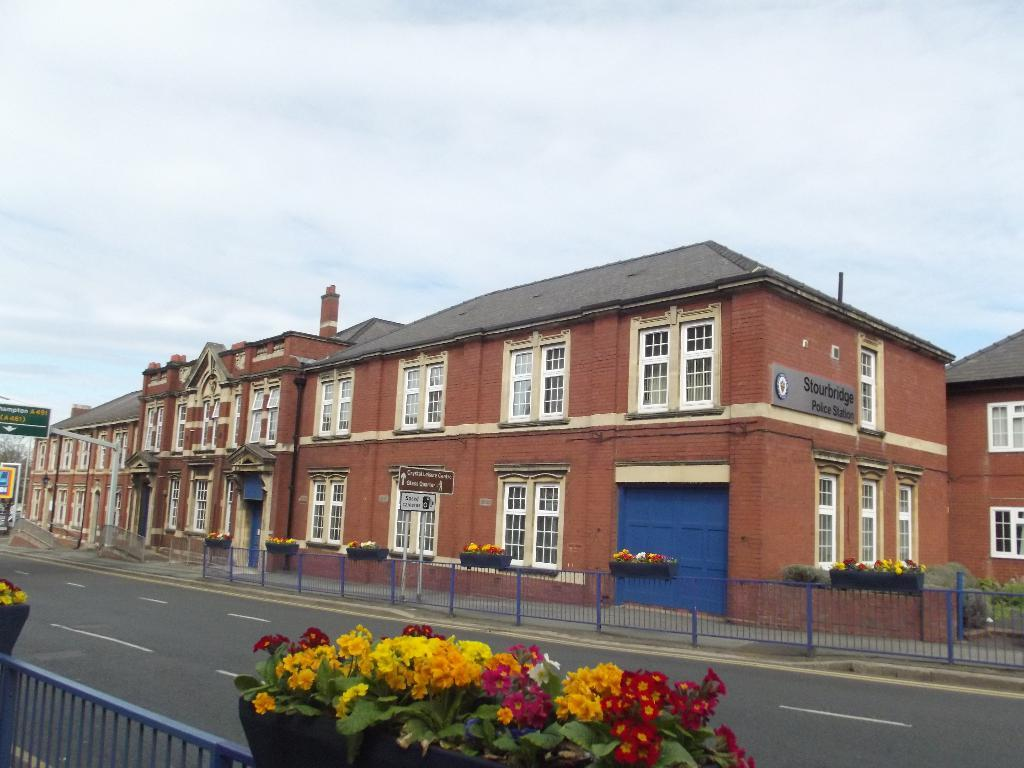What type of structures can be seen in the image? There are buildings in the image. What architectural feature is visible on the buildings? Grilles are visible in the image. What type of vegetation is present at the bottom of the image? There are flowers at the bottom of the image. What other type of vegetation can be seen in the image? Plants are present in the image. Where is the board located in the image? The board is on the left side of the image. What is visible in the background of the image? The sky is visible in the background of the image. What type of linen is draped over the board in the image? There is no linen present in the image; the board is not draped with any fabric. What letters are visible on the board in the image? There are no letters visible on the board in the image. 